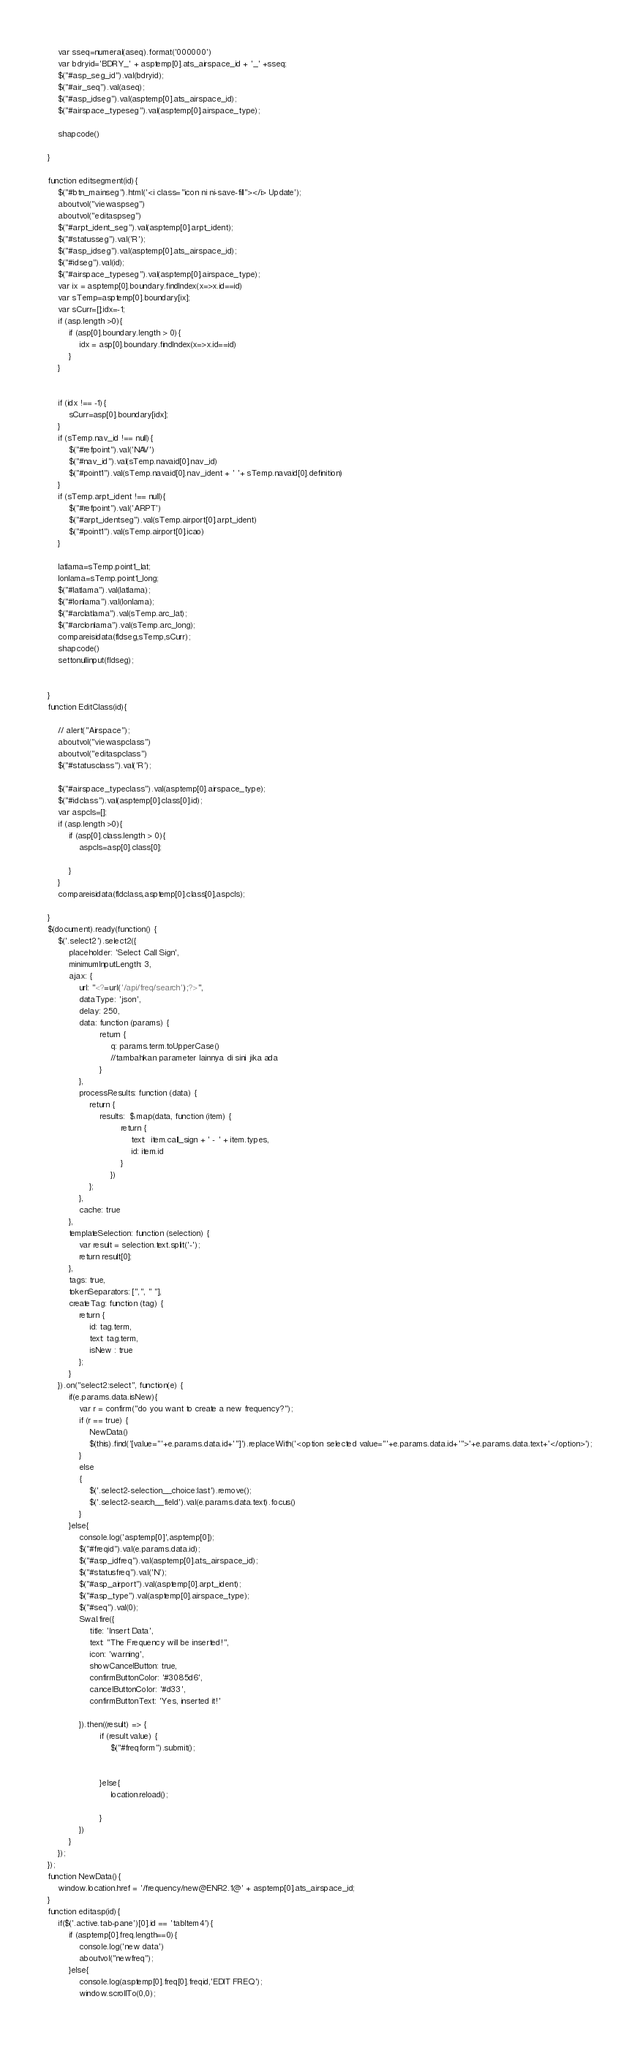<code> <loc_0><loc_0><loc_500><loc_500><_PHP_>    var sseq=numeral(aseq).format('000000')
    var bdryid='BDRY_' + asptemp[0].ats_airspace_id + '_' +sseq;
    $("#asp_seg_id").val(bdryid);
    $("#air_seq").val(aseq);
    $("#asp_idseg").val(asptemp[0].ats_airspace_id);
    $("#airspace_typeseg").val(asptemp[0].airspace_type);
   
    shapcode()
    
}

function editsegment(id){
    $("#btn_mainseg").html('<i class="icon ni ni-save-fill"></i> Update');
    aboutvol("viewaspseg")
    aboutvol("editaspseg")
    $("#arpt_ident_seg").val(asptemp[0].arpt_ident);
    $("#statusseg").val('R');
    $("#asp_idseg").val(asptemp[0].ats_airspace_id);
    $("#idseg").val(id);
    $("#airspace_typeseg").val(asptemp[0].airspace_type);
    var ix = asptemp[0].boundary.findIndex(x=>x.id==id)
    var sTemp=asptemp[0].boundary[ix];
    var sCurr=[];idx=-1;
    if (asp.length >0){
        if (asp[0].boundary.length > 0){
            idx = asp[0].boundary.findIndex(x=>x.id==id)
        }
    }
   
   
    if (idx !== -1){
        sCurr=asp[0].boundary[idx];
    }
    if (sTemp.nav_id !== null){
        $("#refpoint").val('NAV')
        $("#nav_id").val(sTemp.navaid[0].nav_id)
        $("#point1").val(sTemp.navaid[0].nav_ident + ' '+ sTemp.navaid[0].definition)
    }
    if (sTemp.arpt_ident !== null){
        $("#refpoint").val('ARPT')
        $("#arpt_identseg").val(sTemp.airport[0].arpt_ident)
        $("#point1").val(sTemp.airport[0].icao)
    }
    
    latlama=sTemp.point1_lat;
    lonlama=sTemp.point1_long;
    $("#latlama").val(latlama);
    $("#lonlama").val(lonlama);
    $("#arclatlama").val(sTemp.arc_lat);
    $("#arclonlama").val(sTemp.arc_long);
    compareisidata(fldseg,sTemp,sCurr);
    shapcode()
    settonullinput(fldseg);
   
    
}
function EditClass(id){

    // alert("Airspace");
    aboutvol("viewaspclass")
    aboutvol("editaspclass")
    $("#statusclass").val('R');
   
    $("#airspace_typeclass").val(asptemp[0].airspace_type);
    $("#idclass").val(asptemp[0].class[0].id);
    var aspcls=[];
    if (asp.length >0){
        if (asp[0].class.length > 0){
            aspcls=asp[0].class[0];

        }
    }
    compareisidata(fldclass,asptemp[0].class[0],aspcls);
    
}
$(document).ready(function() {
    $('.select2').select2({
        placeholder: 'Select Call Sign',
        minimumInputLength: 3,
        ajax: {
            url: "<?=url('/api/freq/search');?>",
            dataType: 'json',
            delay: 250,
            data: function (params) {
                    return {
                        q: params.term.toUpperCase()
                        //tambahkan parameter lainnya di sini jika ada
                    }
            },
            processResults: function (data) {
                return {
                    results:  $.map(data, function (item) {
                            return {
                                text:  item.call_sign + ' - ' + item.types,
                                id: item.id
                            }
                        })
                };
            },
            cache: true
        },
        templateSelection: function (selection) {
            var result = selection.text.split('-');
            return result[0];
        },
        tags: true,
        tokenSeparators: [",", " "],
        createTag: function (tag) {
            return {
                id: tag.term,
                text: tag.term,
                isNew : true
            };
        }
    }).on("select2:select", function(e) {
        if(e.params.data.isNew){
            var r = confirm("do you want to create a new frequency?");
            if (r == true) {
                NewData()
                $(this).find('[value="'+e.params.data.id+'"]').replaceWith('<option selected value="'+e.params.data.id+'">'+e.params.data.text+'</option>');
            }
            else
            {
                $('.select2-selection__choice:last').remove();
                $('.select2-search__field').val(e.params.data.text).focus()
            }
        }else{
            console.log('asptemp[0]',asptemp[0]);
            $("#freqid").val(e.params.data.id);
            $("#asp_idfreq").val(asptemp[0].ats_airspace_id);
            $("#statusfreq").val('N');
            $("#asp_airport").val(asptemp[0].arpt_ident);
            $("#asp_type").val(asptemp[0].airspace_type);
            $("#seq").val(0);
            Swal.fire({
                title: 'Insert Data',
                text: "The Frequency will be inserted!",
                icon: 'warning',
                showCancelButton: true,
                confirmButtonColor: '#3085d6',
                cancelButtonColor: '#d33',
                confirmButtonText: 'Yes, inserted it!'

            }).then((result) => {
                    if (result.value) {
                        $("#freqform").submit();

                        
                    }else{
                        location.reload();

                    }
            })
        }
    });
});
function NewData(){
    window.location.href = '/frequency/new@ENR2.1@' + asptemp[0].ats_airspace_id;
}
function editasp(id){
    if($('.active.tab-pane')[0].id == 'tabItem4'){
        if (asptemp[0].freq.length==0){
            console.log('new data')
            aboutvol("newfreq");
        }else{
            console.log(asptemp[0].freq[0].freqid,'EDIT FREQ');
            window.scrollTo(0,0);</code> 